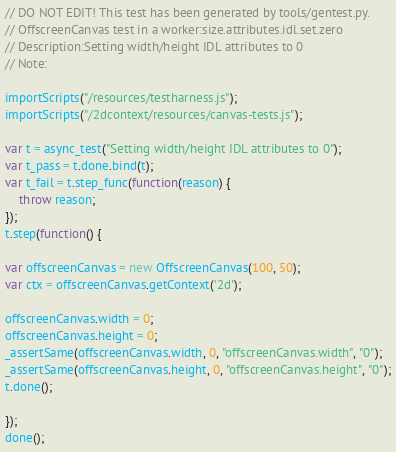<code> <loc_0><loc_0><loc_500><loc_500><_JavaScript_>// DO NOT EDIT! This test has been generated by tools/gentest.py.
// OffscreenCanvas test in a worker:size.attributes.idl.set.zero
// Description:Setting width/height IDL attributes to 0
// Note:

importScripts("/resources/testharness.js");
importScripts("/2dcontext/resources/canvas-tests.js");

var t = async_test("Setting width/height IDL attributes to 0");
var t_pass = t.done.bind(t);
var t_fail = t.step_func(function(reason) {
    throw reason;
});
t.step(function() {

var offscreenCanvas = new OffscreenCanvas(100, 50);
var ctx = offscreenCanvas.getContext('2d');

offscreenCanvas.width = 0;
offscreenCanvas.height = 0;
_assertSame(offscreenCanvas.width, 0, "offscreenCanvas.width", "0");
_assertSame(offscreenCanvas.height, 0, "offscreenCanvas.height", "0");
t.done();

});
done();
</code> 